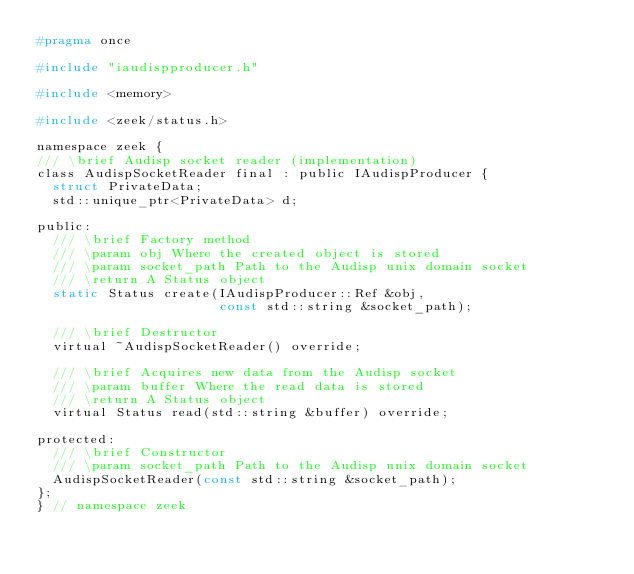<code> <loc_0><loc_0><loc_500><loc_500><_C_>#pragma once

#include "iaudispproducer.h"

#include <memory>

#include <zeek/status.h>

namespace zeek {
/// \brief Audisp socket reader (implementation)
class AudispSocketReader final : public IAudispProducer {
  struct PrivateData;
  std::unique_ptr<PrivateData> d;

public:
  /// \brief Factory method
  /// \param obj Where the created object is stored
  /// \param socket_path Path to the Audisp unix domain socket
  /// \return A Status object
  static Status create(IAudispProducer::Ref &obj,
                       const std::string &socket_path);

  /// \brief Destructor
  virtual ~AudispSocketReader() override;

  /// \brief Acquires new data from the Audisp socket
  /// \param buffer Where the read data is stored
  /// \return A Status object
  virtual Status read(std::string &buffer) override;

protected:
  /// \brief Constructor
  /// \param socket_path Path to the Audisp unix domain socket
  AudispSocketReader(const std::string &socket_path);
};
} // namespace zeek
</code> 